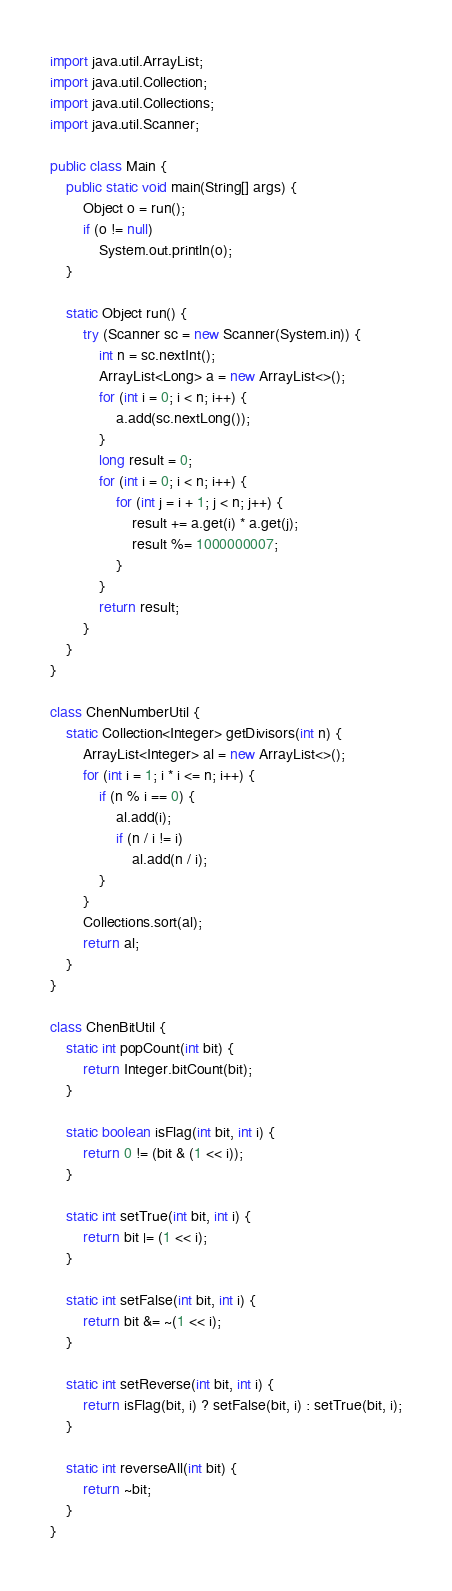Convert code to text. <code><loc_0><loc_0><loc_500><loc_500><_Java_>import java.util.ArrayList;
import java.util.Collection;
import java.util.Collections;
import java.util.Scanner;

public class Main {
    public static void main(String[] args) {
        Object o = run();
        if (o != null)
            System.out.println(o);
    }

    static Object run() {
        try (Scanner sc = new Scanner(System.in)) {
            int n = sc.nextInt();
            ArrayList<Long> a = new ArrayList<>();
            for (int i = 0; i < n; i++) {
                a.add(sc.nextLong());
            }
            long result = 0;
            for (int i = 0; i < n; i++) {
                for (int j = i + 1; j < n; j++) {
                    result += a.get(i) * a.get(j);
                    result %= 1000000007;
                }
            }
            return result;
        }
    }
}

class ChenNumberUtil {
    static Collection<Integer> getDivisors(int n) {
        ArrayList<Integer> al = new ArrayList<>();
        for (int i = 1; i * i <= n; i++) {
            if (n % i == 0) {
                al.add(i);
                if (n / i != i)
                    al.add(n / i);
            }
        }
        Collections.sort(al);
        return al;
    }
}

class ChenBitUtil {
    static int popCount(int bit) {
        return Integer.bitCount(bit);
    }

    static boolean isFlag(int bit, int i) {
        return 0 != (bit & (1 << i));
    }

    static int setTrue(int bit, int i) {
        return bit |= (1 << i);
    }

    static int setFalse(int bit, int i) {
        return bit &= ~(1 << i);
    }

    static int setReverse(int bit, int i) {
        return isFlag(bit, i) ? setFalse(bit, i) : setTrue(bit, i);
    }

    static int reverseAll(int bit) {
        return ~bit;
    }
}</code> 